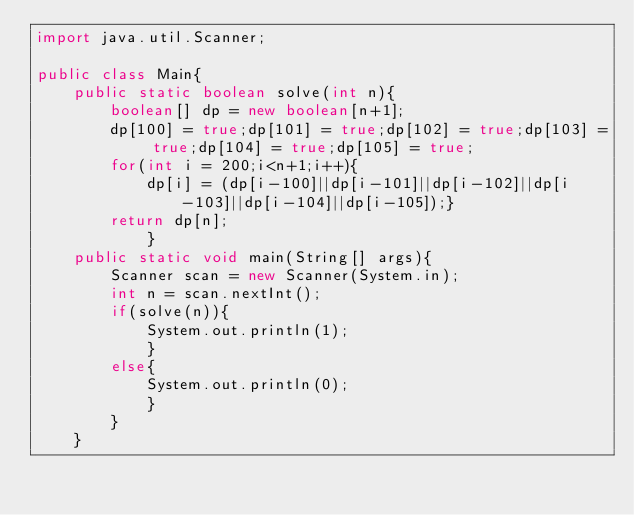Convert code to text. <code><loc_0><loc_0><loc_500><loc_500><_Java_>import java.util.Scanner;

public class Main{
	public static boolean solve(int n){
		boolean[] dp = new boolean[n+1];
		dp[100] = true;dp[101] = true;dp[102] = true;dp[103] = true;dp[104] = true;dp[105] = true;
		for(int i = 200;i<n+1;i++){
			dp[i] = (dp[i-100]||dp[i-101]||dp[i-102]||dp[i-103]||dp[i-104]||dp[i-105]);}
		return dp[n];
			}
	public static void main(String[] args){
		Scanner scan = new Scanner(System.in);
		int n = scan.nextInt();
		if(solve(n)){
			System.out.println(1);
			}
		else{
			System.out.println(0);
			}
		}
	}</code> 